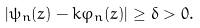Convert formula to latex. <formula><loc_0><loc_0><loc_500><loc_500>| \psi _ { n } ( z ) - k \varphi _ { n } ( z ) | \geq \delta > 0 .</formula> 